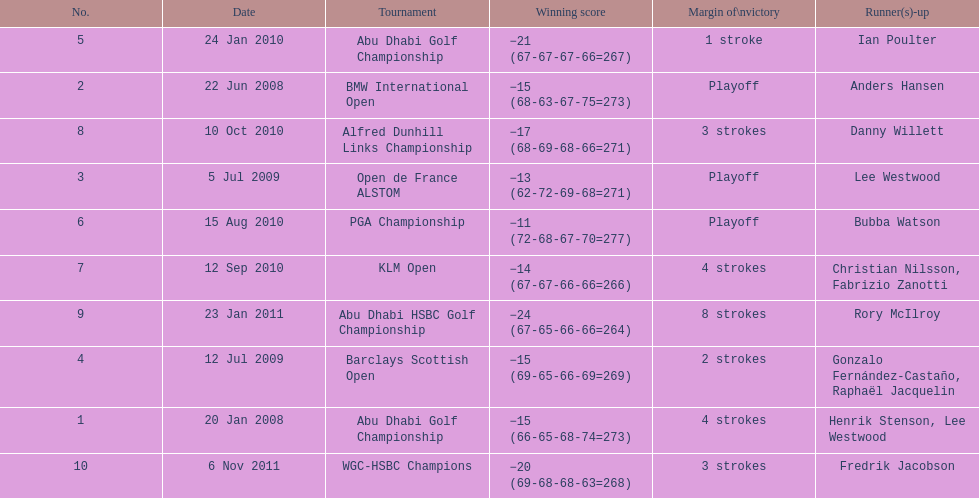Which tournaments did martin kaymer participate in? Abu Dhabi Golf Championship, BMW International Open, Open de France ALSTOM, Barclays Scottish Open, Abu Dhabi Golf Championship, PGA Championship, KLM Open, Alfred Dunhill Links Championship, Abu Dhabi HSBC Golf Championship, WGC-HSBC Champions. How many of these tournaments were won through a playoff? BMW International Open, Open de France ALSTOM, PGA Championship. Which of those tournaments took place in 2010? PGA Championship. Who had to top score next to martin kaymer for that tournament? Bubba Watson. 